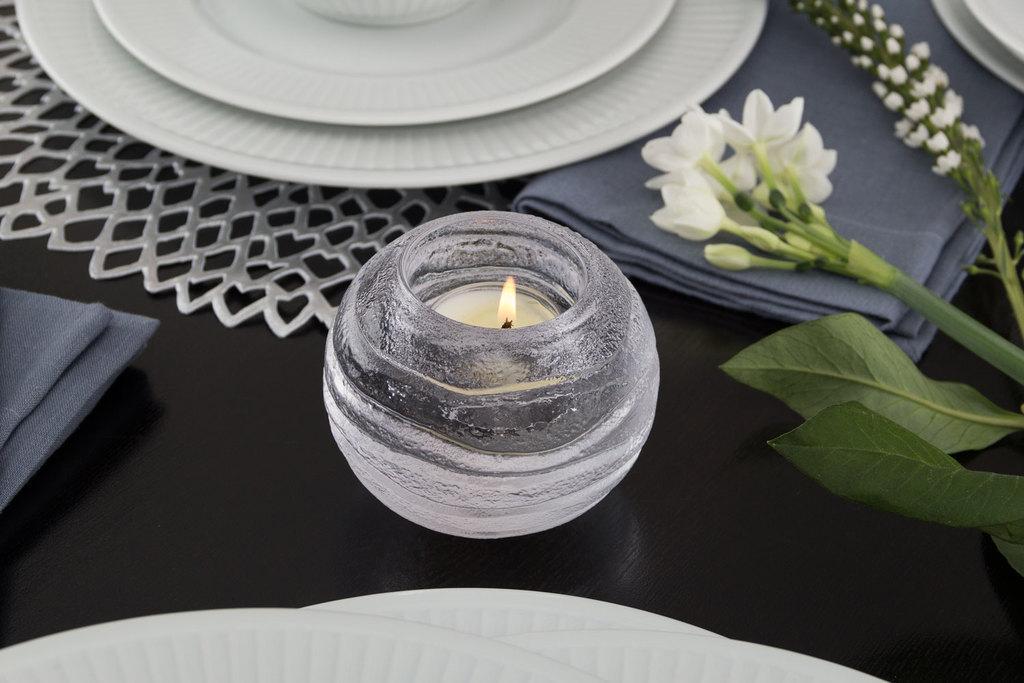How would you summarize this image in a sentence or two? In this picture I can see a candle, flowers to the stem, some plates and some cloth placed on the table. 